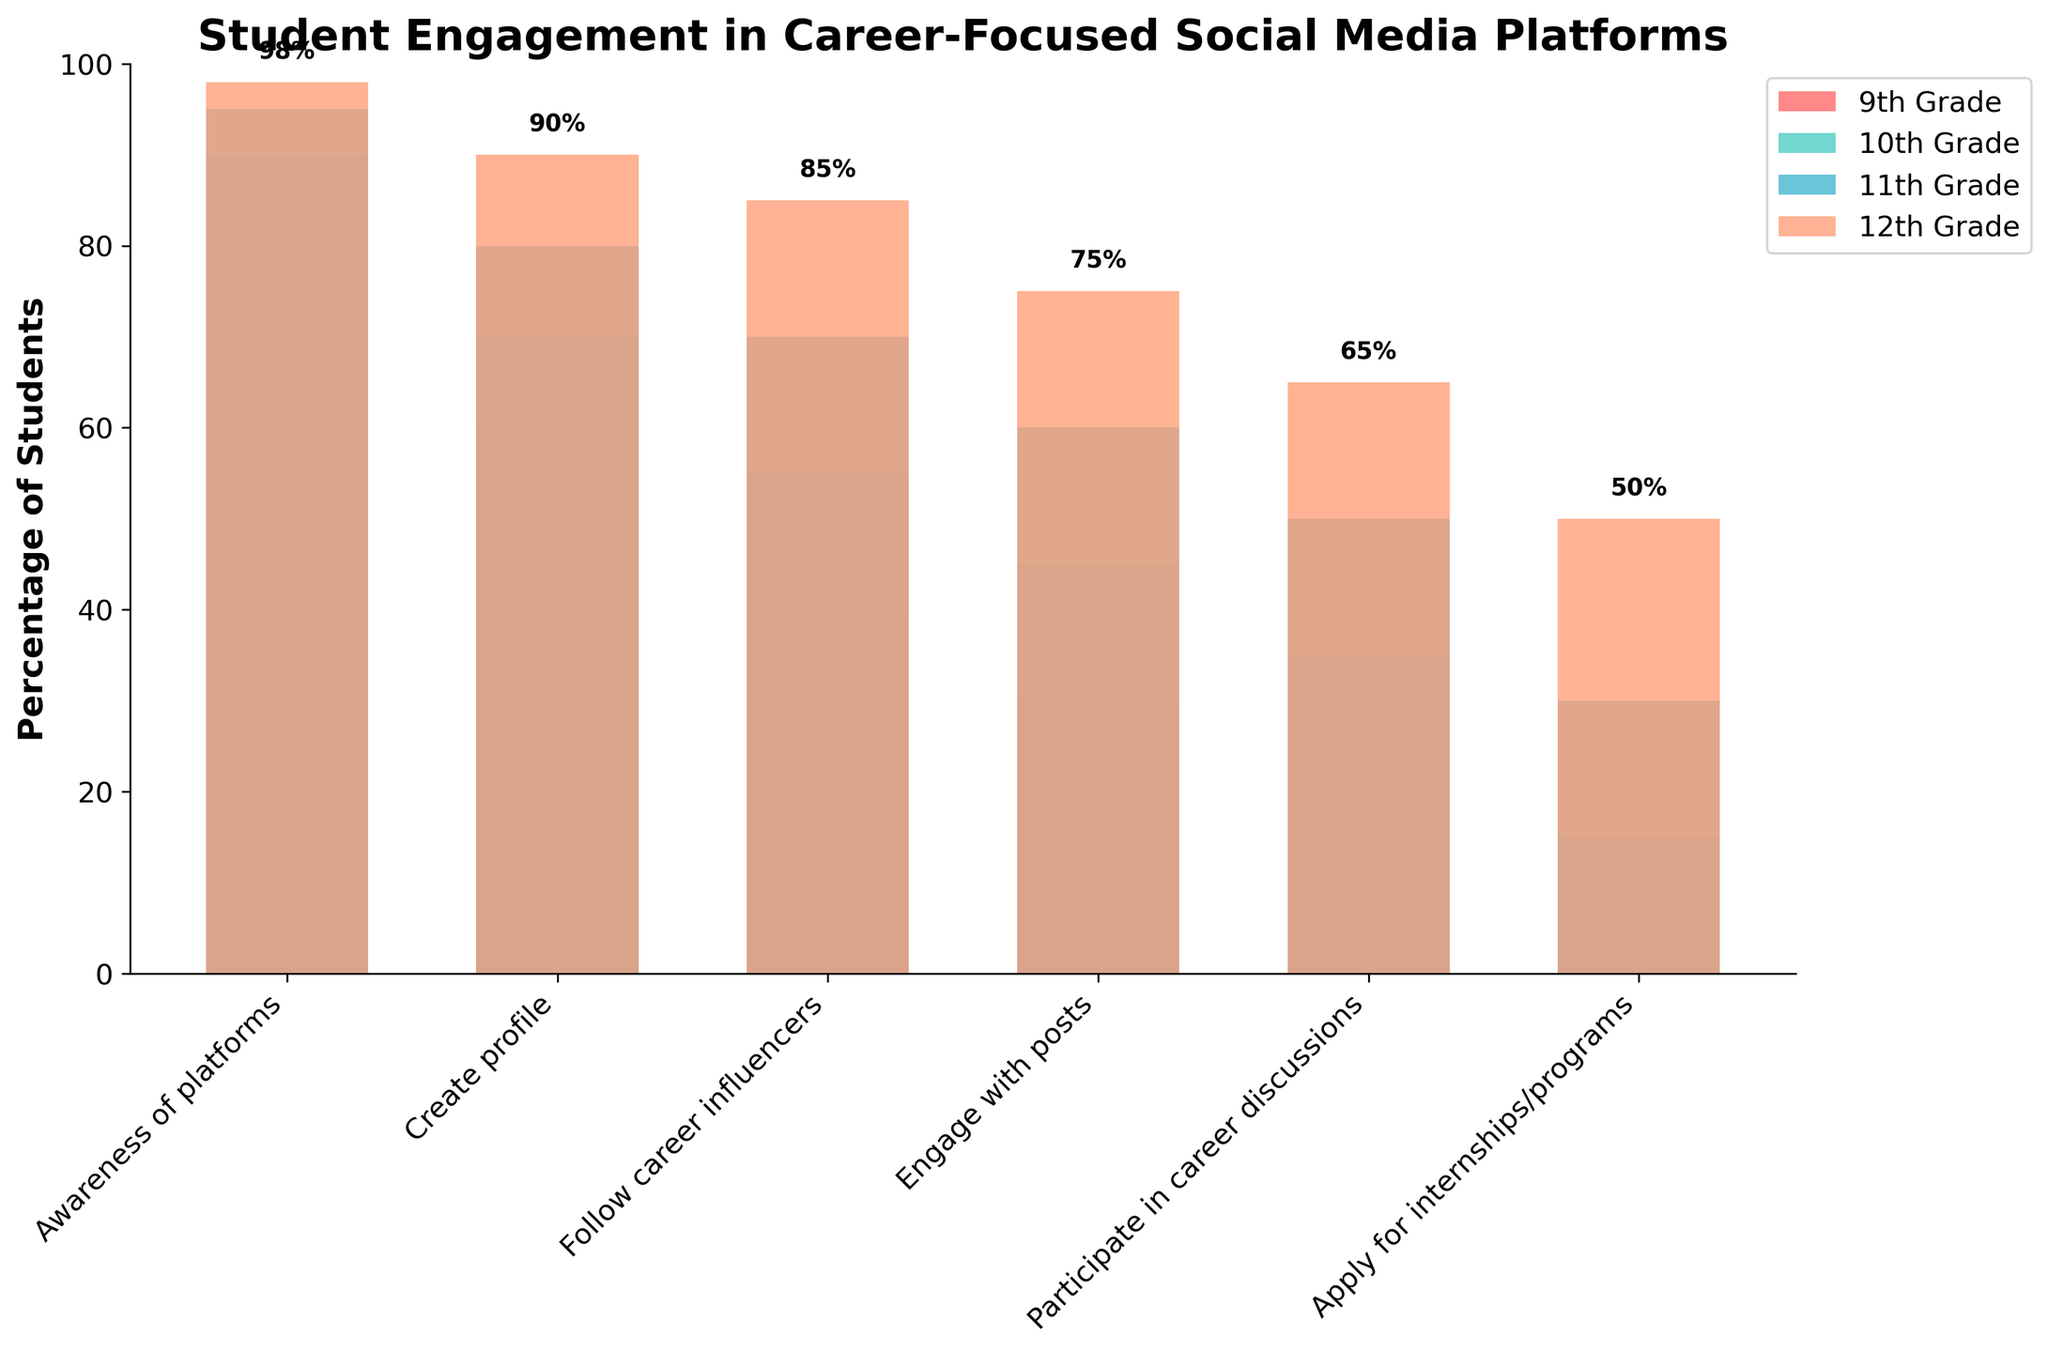What is the title of the figure? The title can be found at the top of the figure. Here, it reads "Student Engagement in Career-Focused Social Media Platforms."
Answer: Student Engagement in Career-Focused Social Media Platforms What is the percentage of 11th graders who engage with posts? Identify the "Engage with posts" stage on the x-axis and locate the corresponding bar for the 11th grade, then read the percentage.
Answer: 60% Which grade has the highest percentage of students applying for internships/programs? Compare the bars for the stage "Apply for internships/programs" across all grades and find the tallest bar.
Answer: 12th Grade Between 9th and 12th grades, how much does the percentage increase for students who participate in career discussions? Find the percentages for "Participate in career discussions" for both grades and subtract the 9th grade percentage from the 12th grade percentage (65% - 20%).
Answer: 45% Which stage shows the lowest average percentage of engagement across all grades? Calculate the average percentage for each stage across all grades, then identify the stage with the lowest average. This involves summing the percentages for each stage and dividing by the number of grades.
Answer: Apply for internships/programs How does awareness of platforms change from 9th to 12th grade? Locate the "Awareness of platforms" stage, then observe and compare the percentages for 9th and 12th grades, noting the increase (98% - 85%).
Answer: It increases by 13% What is the median percentage for students following career influencers across all grades? Find the percentages for "Follow career influencers" for each grade (40%, 55%, 70%, 85%), then determine the median value.
Answer: 62.5% In which stage do we see the biggest increase in student engagement between 9th and 12th grades? Calculate the increase for each stage by subtracting the 9th grade percentage from the 12th grade percentage and compare the increases; the stage with the largest value is the answer.
Answer: Applying for internships/programs Which stage has a percentage drop from the previous stage, and for which grade(s)? Examine each grade individually and compare the percentages of each successive stage; identify where the percentage decreases instead of increases.
Answer: No stage has a percentage drop 